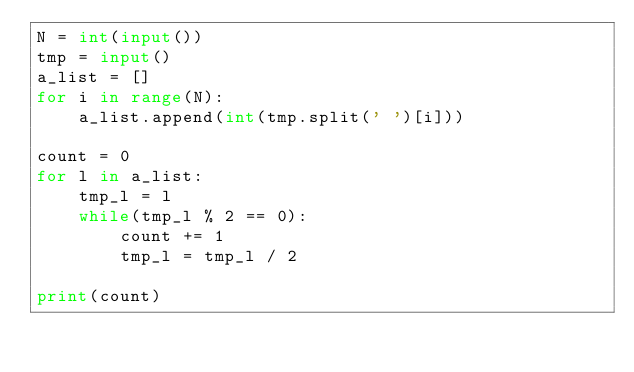Convert code to text. <code><loc_0><loc_0><loc_500><loc_500><_Python_>N = int(input())
tmp = input()
a_list = []
for i in range(N):
    a_list.append(int(tmp.split(' ')[i]))

count = 0
for l in a_list:
    tmp_l = l
    while(tmp_l % 2 == 0):
        count += 1
        tmp_l = tmp_l / 2

print(count)
</code> 